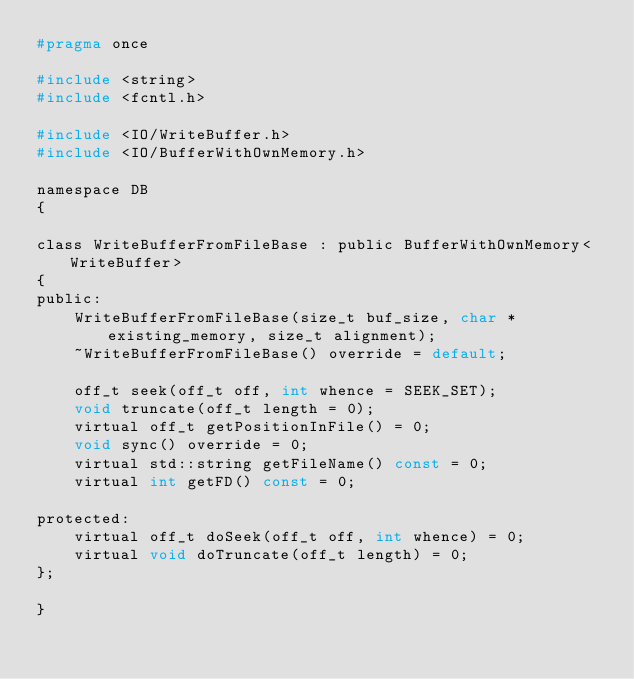Convert code to text. <code><loc_0><loc_0><loc_500><loc_500><_C_>#pragma once

#include <string>
#include <fcntl.h>

#include <IO/WriteBuffer.h>
#include <IO/BufferWithOwnMemory.h>

namespace DB
{

class WriteBufferFromFileBase : public BufferWithOwnMemory<WriteBuffer>
{
public:
    WriteBufferFromFileBase(size_t buf_size, char * existing_memory, size_t alignment);
    ~WriteBufferFromFileBase() override = default;

    off_t seek(off_t off, int whence = SEEK_SET);
    void truncate(off_t length = 0);
    virtual off_t getPositionInFile() = 0;
    void sync() override = 0;
    virtual std::string getFileName() const = 0;
    virtual int getFD() const = 0;

protected:
    virtual off_t doSeek(off_t off, int whence) = 0;
    virtual void doTruncate(off_t length) = 0;
};

}
</code> 